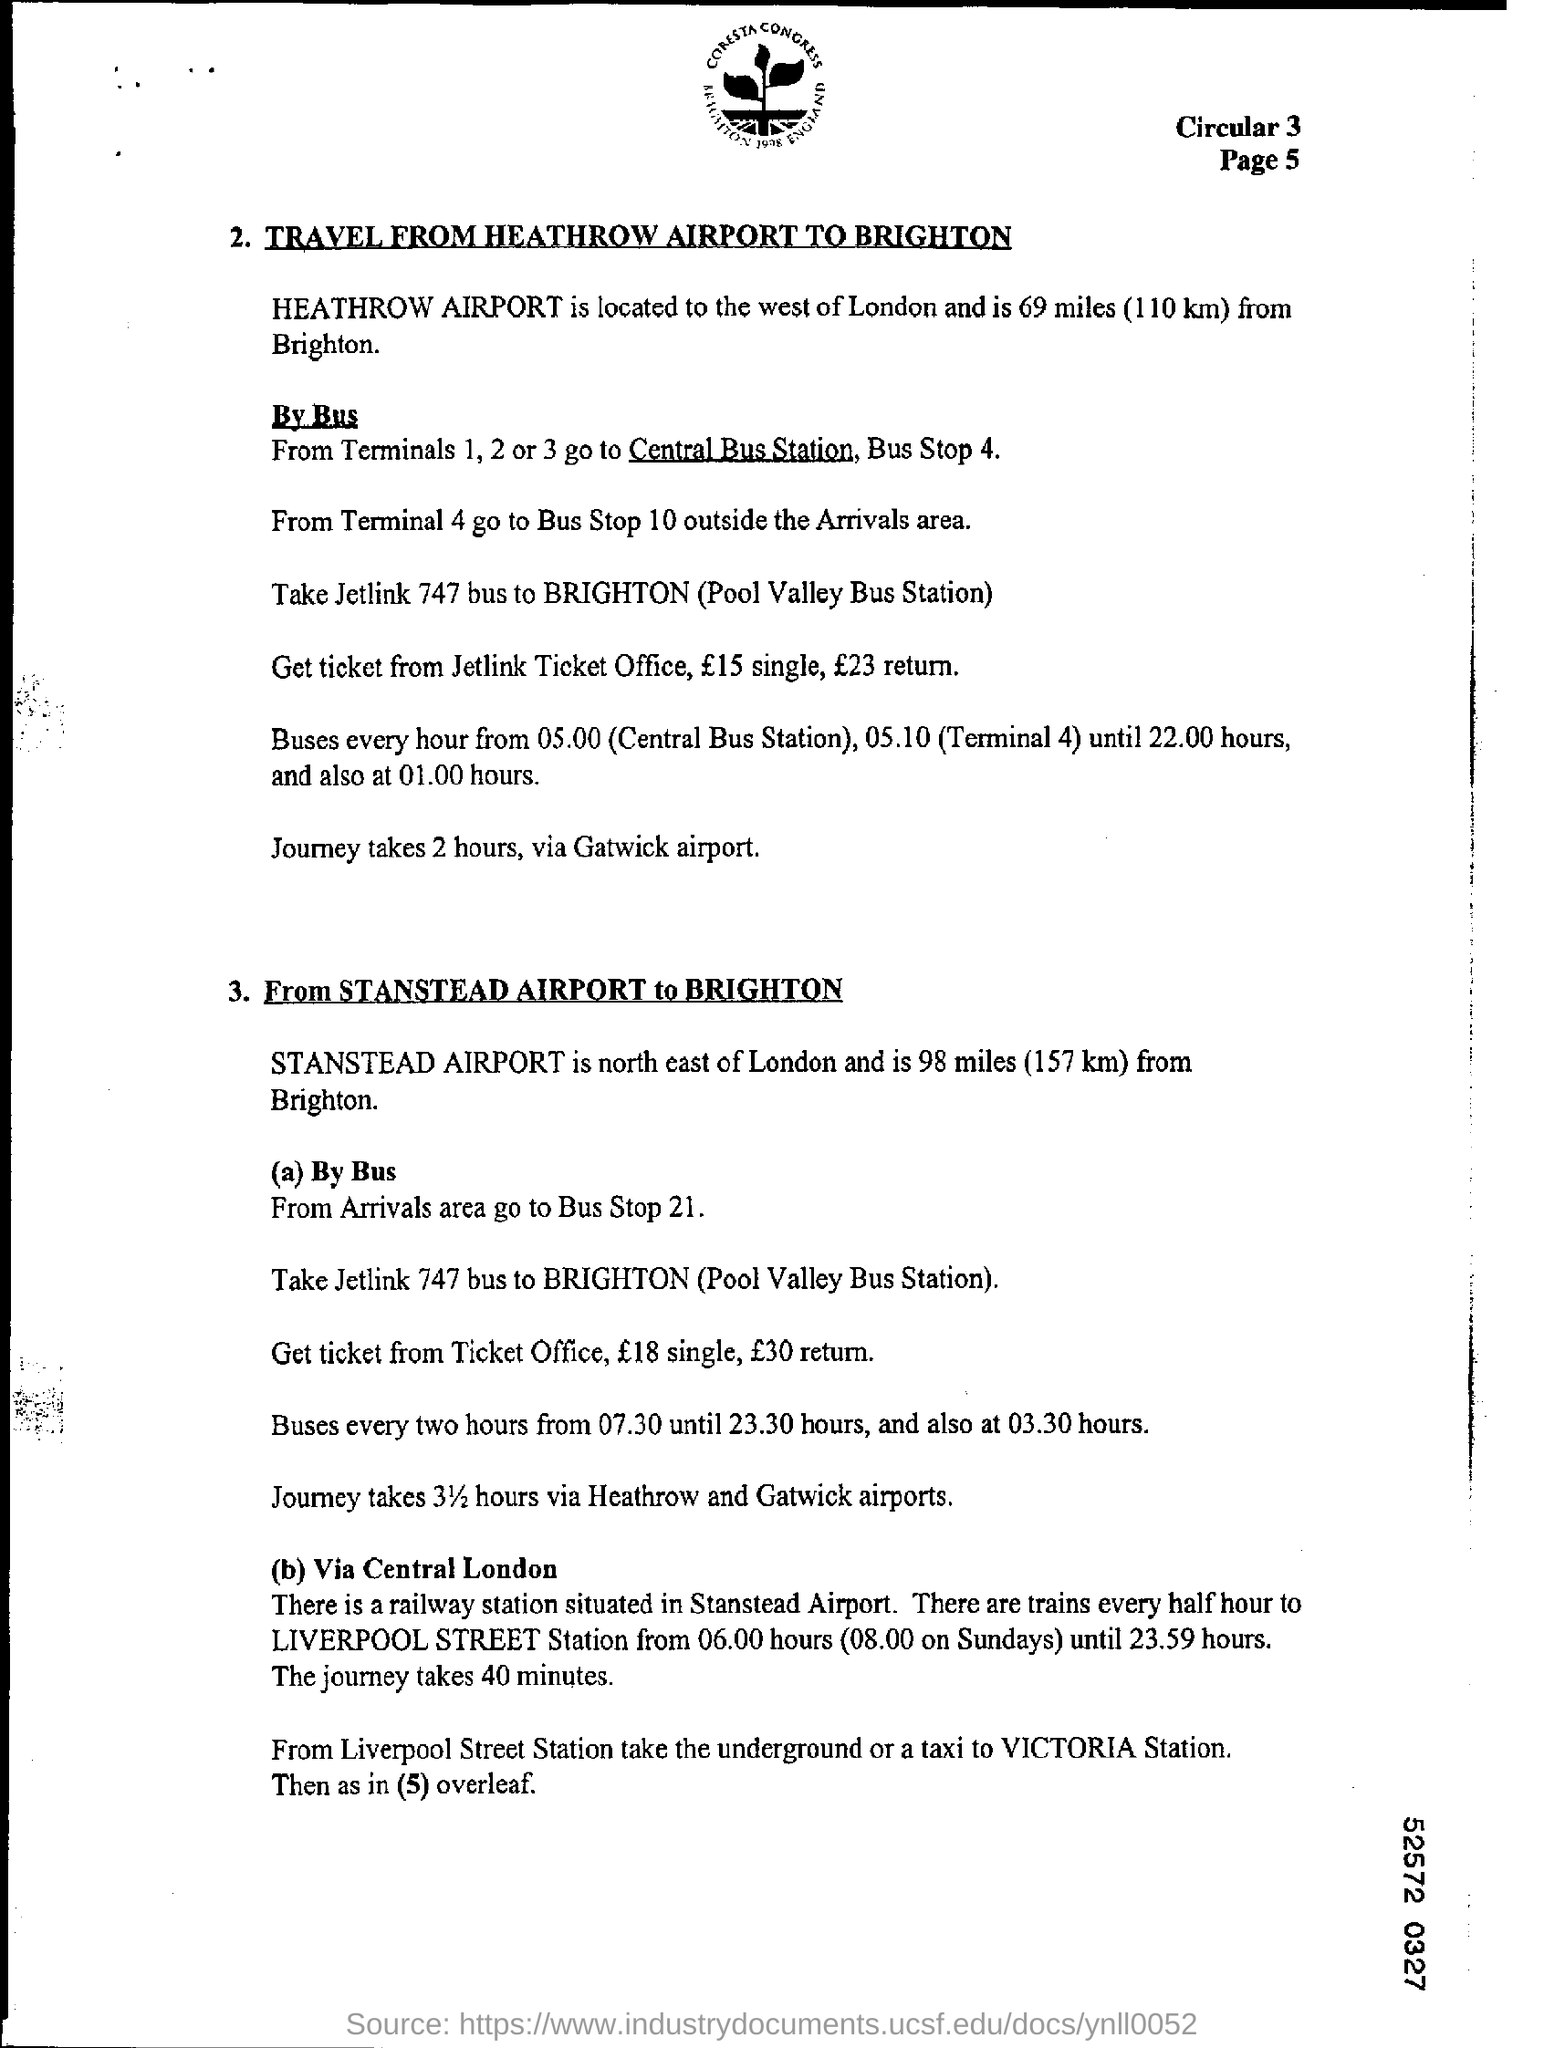Give some essential details in this illustration. Mention the page number at the top right corner of the page, specifically page 5. It is necessary to take the Jetlink 747 bus to Brighton. 